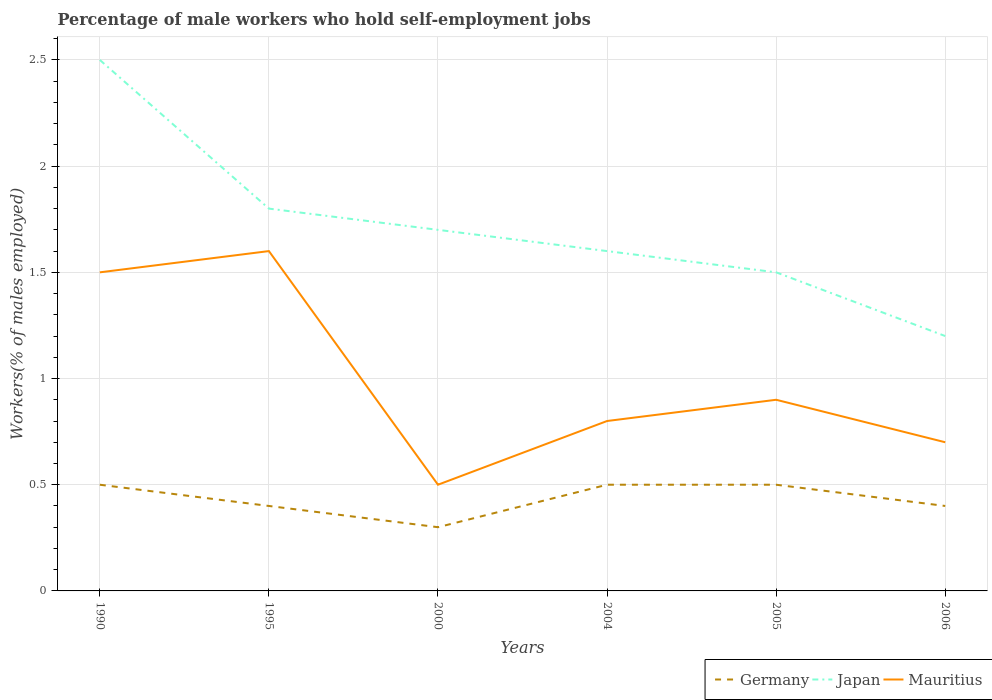Does the line corresponding to Mauritius intersect with the line corresponding to Japan?
Keep it short and to the point. No. Is the number of lines equal to the number of legend labels?
Keep it short and to the point. Yes. Across all years, what is the maximum percentage of self-employed male workers in Mauritius?
Provide a succinct answer. 0.5. In which year was the percentage of self-employed male workers in Germany maximum?
Your answer should be very brief. 2000. What is the total percentage of self-employed male workers in Mauritius in the graph?
Your answer should be compact. -0.3. What is the difference between the highest and the second highest percentage of self-employed male workers in Mauritius?
Offer a very short reply. 1.1. What is the difference between the highest and the lowest percentage of self-employed male workers in Germany?
Your answer should be very brief. 3. How many years are there in the graph?
Your answer should be very brief. 6. Are the values on the major ticks of Y-axis written in scientific E-notation?
Provide a succinct answer. No. How many legend labels are there?
Offer a very short reply. 3. What is the title of the graph?
Ensure brevity in your answer.  Percentage of male workers who hold self-employment jobs. Does "Bulgaria" appear as one of the legend labels in the graph?
Make the answer very short. No. What is the label or title of the X-axis?
Make the answer very short. Years. What is the label or title of the Y-axis?
Ensure brevity in your answer.  Workers(% of males employed). What is the Workers(% of males employed) of Mauritius in 1990?
Keep it short and to the point. 1.5. What is the Workers(% of males employed) in Germany in 1995?
Your answer should be very brief. 0.4. What is the Workers(% of males employed) of Japan in 1995?
Provide a short and direct response. 1.8. What is the Workers(% of males employed) of Mauritius in 1995?
Ensure brevity in your answer.  1.6. What is the Workers(% of males employed) in Germany in 2000?
Offer a very short reply. 0.3. What is the Workers(% of males employed) in Japan in 2000?
Keep it short and to the point. 1.7. What is the Workers(% of males employed) in Mauritius in 2000?
Make the answer very short. 0.5. What is the Workers(% of males employed) of Germany in 2004?
Offer a very short reply. 0.5. What is the Workers(% of males employed) in Japan in 2004?
Your answer should be compact. 1.6. What is the Workers(% of males employed) in Mauritius in 2004?
Provide a succinct answer. 0.8. What is the Workers(% of males employed) of Germany in 2005?
Offer a very short reply. 0.5. What is the Workers(% of males employed) in Mauritius in 2005?
Make the answer very short. 0.9. What is the Workers(% of males employed) of Germany in 2006?
Ensure brevity in your answer.  0.4. What is the Workers(% of males employed) in Japan in 2006?
Your answer should be compact. 1.2. What is the Workers(% of males employed) in Mauritius in 2006?
Your answer should be compact. 0.7. Across all years, what is the maximum Workers(% of males employed) of Mauritius?
Your answer should be very brief. 1.6. Across all years, what is the minimum Workers(% of males employed) in Germany?
Your answer should be very brief. 0.3. Across all years, what is the minimum Workers(% of males employed) in Japan?
Ensure brevity in your answer.  1.2. Across all years, what is the minimum Workers(% of males employed) in Mauritius?
Your answer should be compact. 0.5. What is the total Workers(% of males employed) in Germany in the graph?
Offer a terse response. 2.6. What is the difference between the Workers(% of males employed) in Germany in 1990 and that in 1995?
Ensure brevity in your answer.  0.1. What is the difference between the Workers(% of males employed) in Mauritius in 1990 and that in 1995?
Keep it short and to the point. -0.1. What is the difference between the Workers(% of males employed) of Germany in 1990 and that in 2000?
Ensure brevity in your answer.  0.2. What is the difference between the Workers(% of males employed) of Mauritius in 1990 and that in 2000?
Ensure brevity in your answer.  1. What is the difference between the Workers(% of males employed) of Germany in 1990 and that in 2004?
Provide a succinct answer. 0. What is the difference between the Workers(% of males employed) of Japan in 1990 and that in 2004?
Provide a short and direct response. 0.9. What is the difference between the Workers(% of males employed) of Mauritius in 1990 and that in 2004?
Provide a short and direct response. 0.7. What is the difference between the Workers(% of males employed) in Germany in 1990 and that in 2005?
Ensure brevity in your answer.  0. What is the difference between the Workers(% of males employed) in Japan in 1990 and that in 2005?
Offer a terse response. 1. What is the difference between the Workers(% of males employed) of Mauritius in 1990 and that in 2005?
Your answer should be very brief. 0.6. What is the difference between the Workers(% of males employed) of Germany in 1990 and that in 2006?
Provide a short and direct response. 0.1. What is the difference between the Workers(% of males employed) of Japan in 1990 and that in 2006?
Keep it short and to the point. 1.3. What is the difference between the Workers(% of males employed) in Japan in 1995 and that in 2000?
Offer a very short reply. 0.1. What is the difference between the Workers(% of males employed) in Germany in 1995 and that in 2004?
Provide a succinct answer. -0.1. What is the difference between the Workers(% of males employed) of Mauritius in 1995 and that in 2004?
Ensure brevity in your answer.  0.8. What is the difference between the Workers(% of males employed) of Mauritius in 1995 and that in 2005?
Your answer should be very brief. 0.7. What is the difference between the Workers(% of males employed) of Germany in 1995 and that in 2006?
Offer a terse response. 0. What is the difference between the Workers(% of males employed) in Japan in 1995 and that in 2006?
Your response must be concise. 0.6. What is the difference between the Workers(% of males employed) in Mauritius in 2000 and that in 2004?
Keep it short and to the point. -0.3. What is the difference between the Workers(% of males employed) of Germany in 2000 and that in 2005?
Offer a very short reply. -0.2. What is the difference between the Workers(% of males employed) in Mauritius in 2000 and that in 2005?
Your answer should be compact. -0.4. What is the difference between the Workers(% of males employed) of Germany in 2000 and that in 2006?
Keep it short and to the point. -0.1. What is the difference between the Workers(% of males employed) in Germany in 2004 and that in 2006?
Your response must be concise. 0.1. What is the difference between the Workers(% of males employed) in Germany in 2005 and that in 2006?
Provide a short and direct response. 0.1. What is the difference between the Workers(% of males employed) of Mauritius in 2005 and that in 2006?
Your answer should be very brief. 0.2. What is the difference between the Workers(% of males employed) in Germany in 1990 and the Workers(% of males employed) in Mauritius in 1995?
Give a very brief answer. -1.1. What is the difference between the Workers(% of males employed) in Germany in 1990 and the Workers(% of males employed) in Japan in 2000?
Ensure brevity in your answer.  -1.2. What is the difference between the Workers(% of males employed) in Germany in 1990 and the Workers(% of males employed) in Japan in 2004?
Your answer should be very brief. -1.1. What is the difference between the Workers(% of males employed) of Japan in 1990 and the Workers(% of males employed) of Mauritius in 2004?
Make the answer very short. 1.7. What is the difference between the Workers(% of males employed) of Japan in 1990 and the Workers(% of males employed) of Mauritius in 2005?
Keep it short and to the point. 1.6. What is the difference between the Workers(% of males employed) in Germany in 1990 and the Workers(% of males employed) in Japan in 2006?
Ensure brevity in your answer.  -0.7. What is the difference between the Workers(% of males employed) of Japan in 1990 and the Workers(% of males employed) of Mauritius in 2006?
Give a very brief answer. 1.8. What is the difference between the Workers(% of males employed) in Germany in 1995 and the Workers(% of males employed) in Japan in 2000?
Offer a very short reply. -1.3. What is the difference between the Workers(% of males employed) of Germany in 1995 and the Workers(% of males employed) of Mauritius in 2000?
Give a very brief answer. -0.1. What is the difference between the Workers(% of males employed) in Japan in 1995 and the Workers(% of males employed) in Mauritius in 2000?
Provide a short and direct response. 1.3. What is the difference between the Workers(% of males employed) of Germany in 1995 and the Workers(% of males employed) of Japan in 2004?
Offer a terse response. -1.2. What is the difference between the Workers(% of males employed) of Germany in 1995 and the Workers(% of males employed) of Mauritius in 2004?
Provide a succinct answer. -0.4. What is the difference between the Workers(% of males employed) of Germany in 1995 and the Workers(% of males employed) of Japan in 2005?
Keep it short and to the point. -1.1. What is the difference between the Workers(% of males employed) in Germany in 1995 and the Workers(% of males employed) in Mauritius in 2005?
Give a very brief answer. -0.5. What is the difference between the Workers(% of males employed) in Japan in 1995 and the Workers(% of males employed) in Mauritius in 2005?
Offer a very short reply. 0.9. What is the difference between the Workers(% of males employed) of Germany in 1995 and the Workers(% of males employed) of Japan in 2006?
Provide a succinct answer. -0.8. What is the difference between the Workers(% of males employed) in Germany in 1995 and the Workers(% of males employed) in Mauritius in 2006?
Give a very brief answer. -0.3. What is the difference between the Workers(% of males employed) of Japan in 2000 and the Workers(% of males employed) of Mauritius in 2004?
Keep it short and to the point. 0.9. What is the difference between the Workers(% of males employed) in Germany in 2000 and the Workers(% of males employed) in Japan in 2005?
Make the answer very short. -1.2. What is the difference between the Workers(% of males employed) in Germany in 2000 and the Workers(% of males employed) in Mauritius in 2005?
Ensure brevity in your answer.  -0.6. What is the difference between the Workers(% of males employed) in Japan in 2000 and the Workers(% of males employed) in Mauritius in 2006?
Make the answer very short. 1. What is the difference between the Workers(% of males employed) of Germany in 2004 and the Workers(% of males employed) of Mauritius in 2006?
Give a very brief answer. -0.2. What is the difference between the Workers(% of males employed) in Germany in 2005 and the Workers(% of males employed) in Japan in 2006?
Make the answer very short. -0.7. What is the difference between the Workers(% of males employed) of Japan in 2005 and the Workers(% of males employed) of Mauritius in 2006?
Your answer should be compact. 0.8. What is the average Workers(% of males employed) of Germany per year?
Keep it short and to the point. 0.43. What is the average Workers(% of males employed) of Japan per year?
Offer a terse response. 1.72. What is the average Workers(% of males employed) in Mauritius per year?
Provide a succinct answer. 1. In the year 1990, what is the difference between the Workers(% of males employed) of Germany and Workers(% of males employed) of Japan?
Your answer should be compact. -2. In the year 2004, what is the difference between the Workers(% of males employed) of Germany and Workers(% of males employed) of Japan?
Your response must be concise. -1.1. In the year 2004, what is the difference between the Workers(% of males employed) in Japan and Workers(% of males employed) in Mauritius?
Your response must be concise. 0.8. In the year 2005, what is the difference between the Workers(% of males employed) of Japan and Workers(% of males employed) of Mauritius?
Make the answer very short. 0.6. In the year 2006, what is the difference between the Workers(% of males employed) in Germany and Workers(% of males employed) in Japan?
Provide a succinct answer. -0.8. In the year 2006, what is the difference between the Workers(% of males employed) of Germany and Workers(% of males employed) of Mauritius?
Provide a succinct answer. -0.3. In the year 2006, what is the difference between the Workers(% of males employed) in Japan and Workers(% of males employed) in Mauritius?
Provide a succinct answer. 0.5. What is the ratio of the Workers(% of males employed) of Japan in 1990 to that in 1995?
Give a very brief answer. 1.39. What is the ratio of the Workers(% of males employed) of Japan in 1990 to that in 2000?
Provide a succinct answer. 1.47. What is the ratio of the Workers(% of males employed) in Mauritius in 1990 to that in 2000?
Your answer should be very brief. 3. What is the ratio of the Workers(% of males employed) of Germany in 1990 to that in 2004?
Keep it short and to the point. 1. What is the ratio of the Workers(% of males employed) in Japan in 1990 to that in 2004?
Make the answer very short. 1.56. What is the ratio of the Workers(% of males employed) in Mauritius in 1990 to that in 2004?
Make the answer very short. 1.88. What is the ratio of the Workers(% of males employed) of Japan in 1990 to that in 2005?
Your answer should be compact. 1.67. What is the ratio of the Workers(% of males employed) of Germany in 1990 to that in 2006?
Make the answer very short. 1.25. What is the ratio of the Workers(% of males employed) of Japan in 1990 to that in 2006?
Offer a terse response. 2.08. What is the ratio of the Workers(% of males employed) in Mauritius in 1990 to that in 2006?
Make the answer very short. 2.14. What is the ratio of the Workers(% of males employed) of Germany in 1995 to that in 2000?
Your response must be concise. 1.33. What is the ratio of the Workers(% of males employed) in Japan in 1995 to that in 2000?
Keep it short and to the point. 1.06. What is the ratio of the Workers(% of males employed) of Mauritius in 1995 to that in 2000?
Your answer should be very brief. 3.2. What is the ratio of the Workers(% of males employed) of Germany in 1995 to that in 2004?
Offer a terse response. 0.8. What is the ratio of the Workers(% of males employed) in Germany in 1995 to that in 2005?
Ensure brevity in your answer.  0.8. What is the ratio of the Workers(% of males employed) in Mauritius in 1995 to that in 2005?
Ensure brevity in your answer.  1.78. What is the ratio of the Workers(% of males employed) of Japan in 1995 to that in 2006?
Provide a succinct answer. 1.5. What is the ratio of the Workers(% of males employed) in Mauritius in 1995 to that in 2006?
Give a very brief answer. 2.29. What is the ratio of the Workers(% of males employed) in Japan in 2000 to that in 2004?
Offer a very short reply. 1.06. What is the ratio of the Workers(% of males employed) in Japan in 2000 to that in 2005?
Make the answer very short. 1.13. What is the ratio of the Workers(% of males employed) of Mauritius in 2000 to that in 2005?
Your answer should be compact. 0.56. What is the ratio of the Workers(% of males employed) of Germany in 2000 to that in 2006?
Ensure brevity in your answer.  0.75. What is the ratio of the Workers(% of males employed) of Japan in 2000 to that in 2006?
Provide a short and direct response. 1.42. What is the ratio of the Workers(% of males employed) in Mauritius in 2000 to that in 2006?
Ensure brevity in your answer.  0.71. What is the ratio of the Workers(% of males employed) in Germany in 2004 to that in 2005?
Make the answer very short. 1. What is the ratio of the Workers(% of males employed) in Japan in 2004 to that in 2005?
Provide a short and direct response. 1.07. What is the ratio of the Workers(% of males employed) of Japan in 2004 to that in 2006?
Your answer should be compact. 1.33. What is the ratio of the Workers(% of males employed) of Mauritius in 2004 to that in 2006?
Provide a succinct answer. 1.14. What is the ratio of the Workers(% of males employed) of Japan in 2005 to that in 2006?
Make the answer very short. 1.25. What is the difference between the highest and the second highest Workers(% of males employed) of Germany?
Your response must be concise. 0. What is the difference between the highest and the lowest Workers(% of males employed) in Japan?
Keep it short and to the point. 1.3. What is the difference between the highest and the lowest Workers(% of males employed) in Mauritius?
Give a very brief answer. 1.1. 